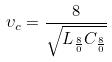Convert formula to latex. <formula><loc_0><loc_0><loc_500><loc_500>\upsilon _ { c } = \frac { 8 } { \sqrt { L _ { \frac { 8 } { 0 } } C _ { \frac { 8 } { 0 } } } }</formula> 